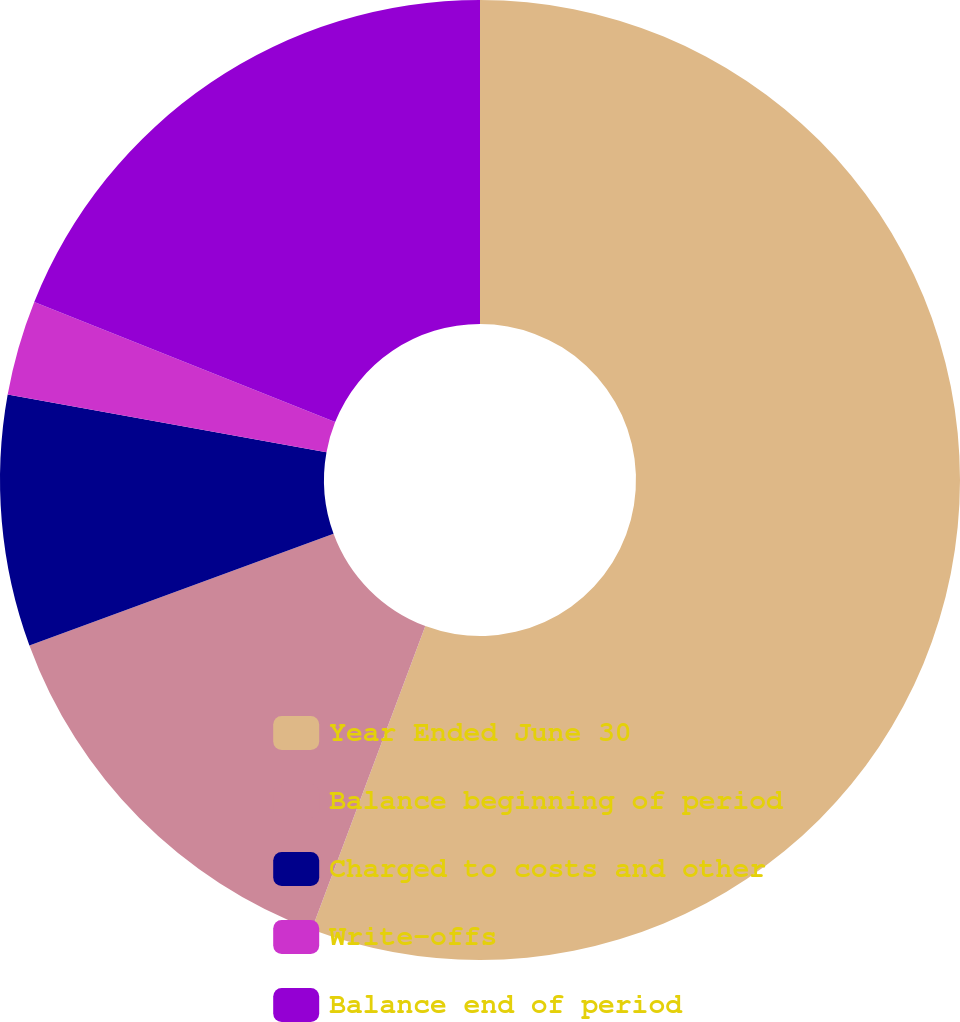<chart> <loc_0><loc_0><loc_500><loc_500><pie_chart><fcel>Year Ended June 30<fcel>Balance beginning of period<fcel>Charged to costs and other<fcel>Write-offs<fcel>Balance end of period<nl><fcel>55.7%<fcel>13.7%<fcel>8.45%<fcel>3.2%<fcel>18.95%<nl></chart> 